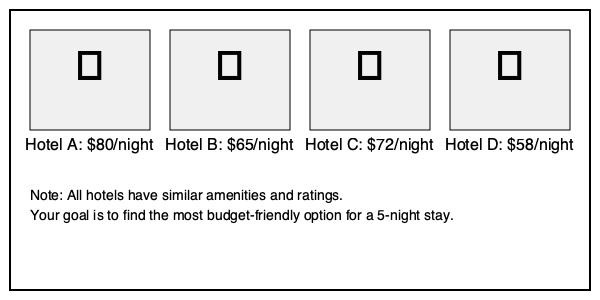Based on the given information about four hotels, which one would be the most budget-friendly choice for a 5-night stay? To determine the most budget-friendly hotel for a 5-night stay, we need to calculate the total cost for each hotel:

1. Hotel A: $80/night
   Total cost = $80 * 5 nights = $400

2. Hotel B: $65/night
   Total cost = $65 * 5 nights = $325

3. Hotel C: $72/night
   Total cost = $72 * 5 nights = $360

4. Hotel D: $58/night
   Total cost = $58 * 5 nights = $290

Comparing the total costs:
Hotel A: $400
Hotel B: $325
Hotel C: $360
Hotel D: $290

Hotel D has the lowest total cost for a 5-night stay at $290, making it the most budget-friendly option.
Answer: Hotel D 